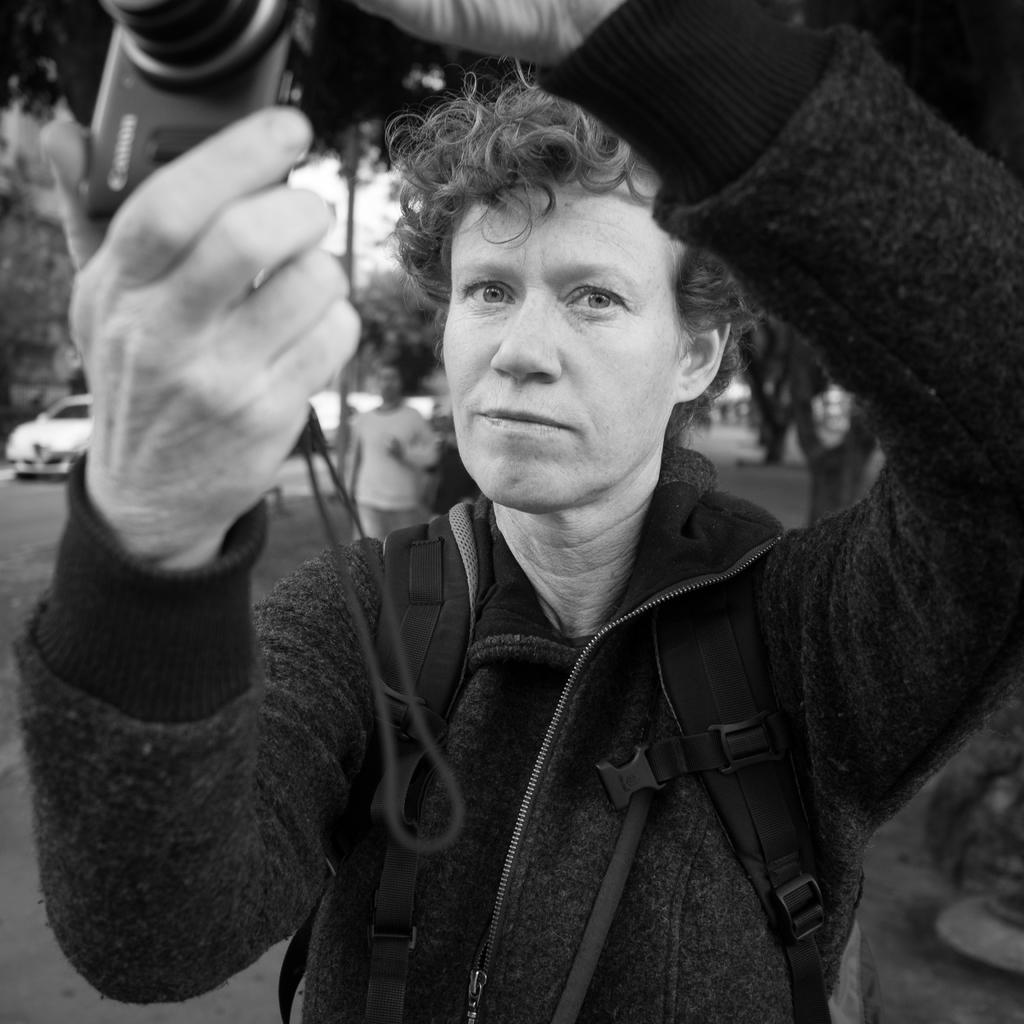What is the man in the image wearing? The man is wearing a jacket. What is the man holding in the image? The man is holding a camera. How would you describe the background of the image? The background is blurred, and there are trees, a vehicle, and people visible. What type of cake is being served to the people in the background? There is no cake present in the image; it only shows the man, his jacket, and the camera he is holding. 